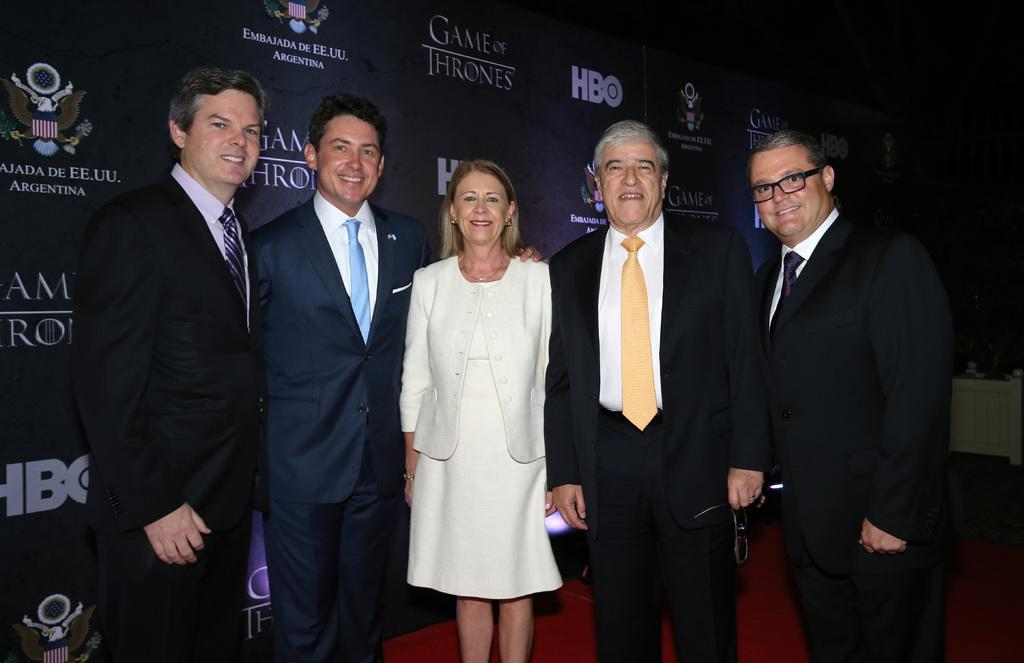How many people are in the foreground of the image? There are four men and a woman in the foreground of the image. What are the individuals in the foreground doing? The individuals are standing and posing for a camera. What can be seen in the background of the image? There is a banner wall in the background of the image. How would you describe the lighting in the image? The background appears to be dark. Can you see a river flowing behind the individuals in the image? There is no river visible in the image; it features a banner wall in the background. What type of soda is being served at the event in the image? There is no mention of any soda or event in the image; it only shows a group of people posing for a camera. 